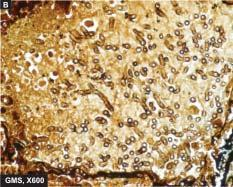re salt bridges best identified with a special stain for fungi, gomory 's methenamine silver gms?
Answer the question using a single word or phrase. No 